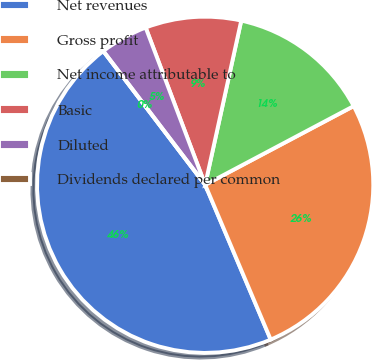Convert chart. <chart><loc_0><loc_0><loc_500><loc_500><pie_chart><fcel>Net revenues<fcel>Gross profit<fcel>Net income attributable to<fcel>Basic<fcel>Diluted<fcel>Dividends declared per common<nl><fcel>46.01%<fcel>26.38%<fcel>13.8%<fcel>9.2%<fcel>4.6%<fcel>0.0%<nl></chart> 